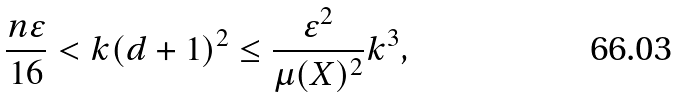<formula> <loc_0><loc_0><loc_500><loc_500>\frac { n \varepsilon } { 1 6 } < k ( d + 1 ) ^ { 2 } \leq \frac { \varepsilon ^ { 2 } } { \mu ( X ) ^ { 2 } } k ^ { 3 } ,</formula> 